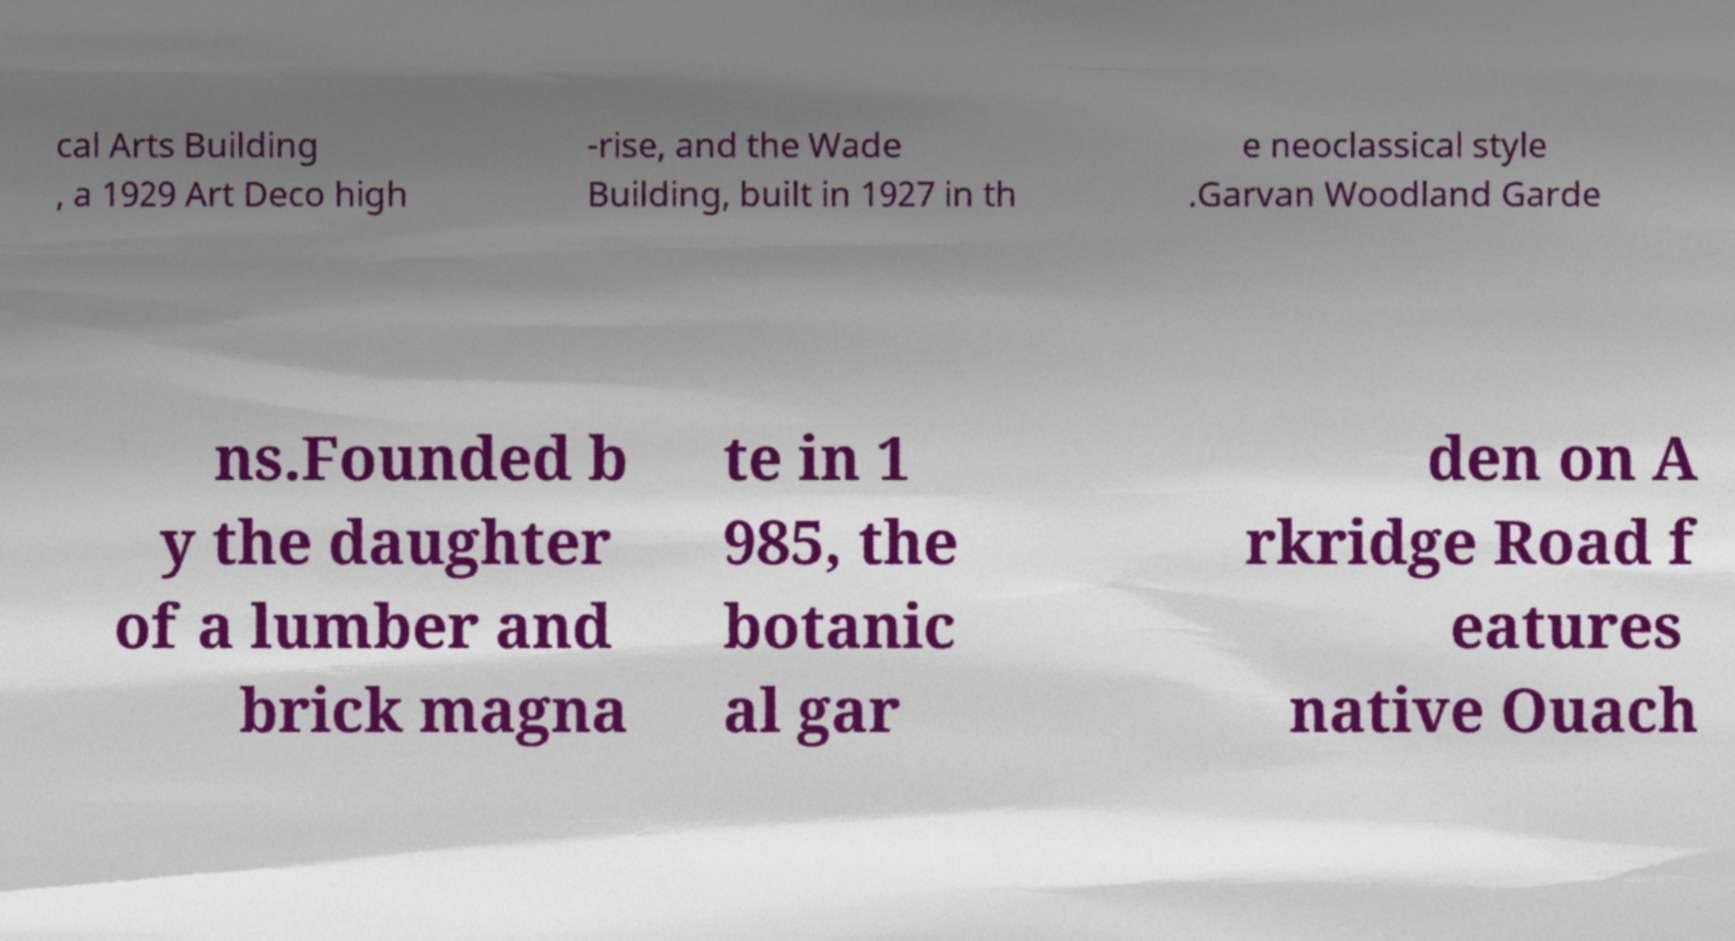Please read and relay the text visible in this image. What does it say? cal Arts Building , a 1929 Art Deco high -rise, and the Wade Building, built in 1927 in th e neoclassical style .Garvan Woodland Garde ns.Founded b y the daughter of a lumber and brick magna te in 1 985, the botanic al gar den on A rkridge Road f eatures native Ouach 